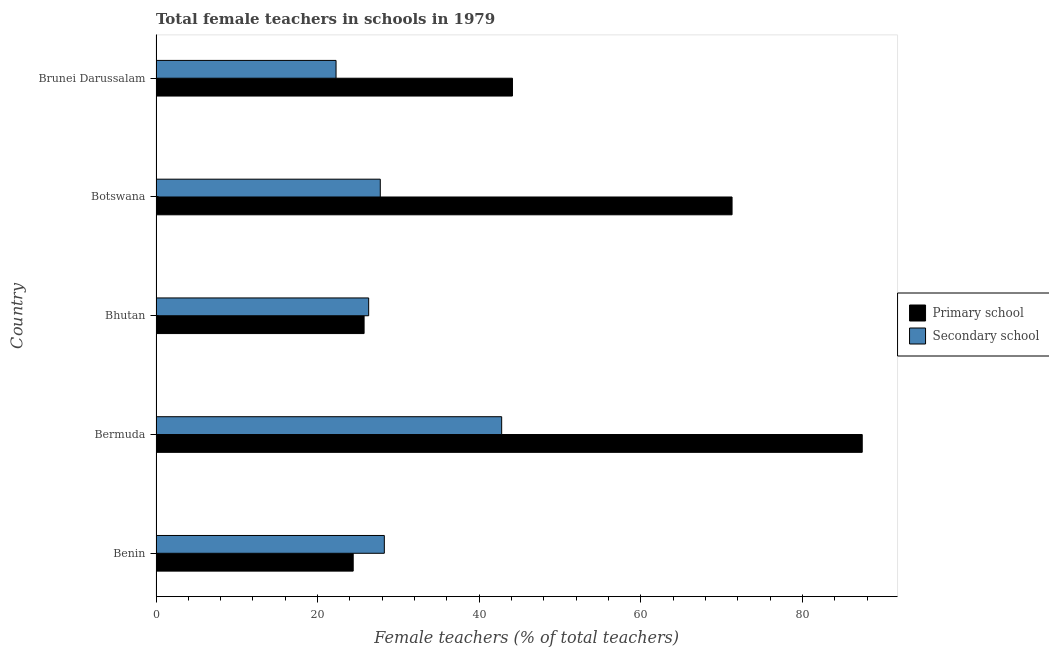How many different coloured bars are there?
Your response must be concise. 2. How many groups of bars are there?
Ensure brevity in your answer.  5. Are the number of bars per tick equal to the number of legend labels?
Your answer should be compact. Yes. Are the number of bars on each tick of the Y-axis equal?
Give a very brief answer. Yes. How many bars are there on the 2nd tick from the top?
Make the answer very short. 2. What is the label of the 1st group of bars from the top?
Provide a succinct answer. Brunei Darussalam. What is the percentage of female teachers in secondary schools in Brunei Darussalam?
Provide a short and direct response. 22.28. Across all countries, what is the maximum percentage of female teachers in primary schools?
Provide a short and direct response. 87.4. Across all countries, what is the minimum percentage of female teachers in primary schools?
Keep it short and to the point. 24.4. In which country was the percentage of female teachers in secondary schools maximum?
Your answer should be very brief. Bermuda. In which country was the percentage of female teachers in secondary schools minimum?
Make the answer very short. Brunei Darussalam. What is the total percentage of female teachers in primary schools in the graph?
Give a very brief answer. 252.97. What is the difference between the percentage of female teachers in primary schools in Benin and that in Botswana?
Make the answer very short. -46.89. What is the difference between the percentage of female teachers in secondary schools in Bermuda and the percentage of female teachers in primary schools in Brunei Darussalam?
Ensure brevity in your answer.  -1.34. What is the average percentage of female teachers in primary schools per country?
Keep it short and to the point. 50.59. What is the difference between the percentage of female teachers in primary schools and percentage of female teachers in secondary schools in Bermuda?
Your response must be concise. 44.62. In how many countries, is the percentage of female teachers in secondary schools greater than 16 %?
Your response must be concise. 5. What is the ratio of the percentage of female teachers in primary schools in Bhutan to that in Botswana?
Your response must be concise. 0.36. Is the difference between the percentage of female teachers in primary schools in Botswana and Brunei Darussalam greater than the difference between the percentage of female teachers in secondary schools in Botswana and Brunei Darussalam?
Offer a terse response. Yes. What is the difference between the highest and the second highest percentage of female teachers in primary schools?
Your response must be concise. 16.11. In how many countries, is the percentage of female teachers in primary schools greater than the average percentage of female teachers in primary schools taken over all countries?
Your response must be concise. 2. What does the 2nd bar from the top in Brunei Darussalam represents?
Your answer should be compact. Primary school. What does the 2nd bar from the bottom in Benin represents?
Keep it short and to the point. Secondary school. How many bars are there?
Offer a very short reply. 10. How many countries are there in the graph?
Provide a short and direct response. 5. What is the difference between two consecutive major ticks on the X-axis?
Keep it short and to the point. 20. Are the values on the major ticks of X-axis written in scientific E-notation?
Provide a succinct answer. No. Does the graph contain any zero values?
Make the answer very short. No. Does the graph contain grids?
Make the answer very short. No. Where does the legend appear in the graph?
Make the answer very short. Center right. How are the legend labels stacked?
Your answer should be very brief. Vertical. What is the title of the graph?
Your answer should be very brief. Total female teachers in schools in 1979. What is the label or title of the X-axis?
Provide a succinct answer. Female teachers (% of total teachers). What is the label or title of the Y-axis?
Provide a succinct answer. Country. What is the Female teachers (% of total teachers) in Primary school in Benin?
Your response must be concise. 24.4. What is the Female teachers (% of total teachers) in Secondary school in Benin?
Your answer should be very brief. 28.26. What is the Female teachers (% of total teachers) of Primary school in Bermuda?
Provide a short and direct response. 87.4. What is the Female teachers (% of total teachers) in Secondary school in Bermuda?
Offer a terse response. 42.78. What is the Female teachers (% of total teachers) in Primary school in Bhutan?
Your answer should be very brief. 25.75. What is the Female teachers (% of total teachers) of Secondary school in Bhutan?
Your answer should be compact. 26.32. What is the Female teachers (% of total teachers) in Primary school in Botswana?
Offer a terse response. 71.29. What is the Female teachers (% of total teachers) of Secondary school in Botswana?
Ensure brevity in your answer.  27.76. What is the Female teachers (% of total teachers) in Primary school in Brunei Darussalam?
Provide a short and direct response. 44.12. What is the Female teachers (% of total teachers) of Secondary school in Brunei Darussalam?
Ensure brevity in your answer.  22.28. Across all countries, what is the maximum Female teachers (% of total teachers) of Primary school?
Make the answer very short. 87.4. Across all countries, what is the maximum Female teachers (% of total teachers) in Secondary school?
Offer a very short reply. 42.78. Across all countries, what is the minimum Female teachers (% of total teachers) in Primary school?
Ensure brevity in your answer.  24.4. Across all countries, what is the minimum Female teachers (% of total teachers) in Secondary school?
Your answer should be compact. 22.28. What is the total Female teachers (% of total teachers) in Primary school in the graph?
Provide a short and direct response. 252.97. What is the total Female teachers (% of total teachers) in Secondary school in the graph?
Your response must be concise. 147.39. What is the difference between the Female teachers (% of total teachers) of Primary school in Benin and that in Bermuda?
Make the answer very short. -63. What is the difference between the Female teachers (% of total teachers) in Secondary school in Benin and that in Bermuda?
Offer a very short reply. -14.52. What is the difference between the Female teachers (% of total teachers) of Primary school in Benin and that in Bhutan?
Ensure brevity in your answer.  -1.35. What is the difference between the Female teachers (% of total teachers) in Secondary school in Benin and that in Bhutan?
Ensure brevity in your answer.  1.94. What is the difference between the Female teachers (% of total teachers) of Primary school in Benin and that in Botswana?
Make the answer very short. -46.89. What is the difference between the Female teachers (% of total teachers) of Secondary school in Benin and that in Botswana?
Your response must be concise. 0.5. What is the difference between the Female teachers (% of total teachers) of Primary school in Benin and that in Brunei Darussalam?
Offer a terse response. -19.71. What is the difference between the Female teachers (% of total teachers) of Secondary school in Benin and that in Brunei Darussalam?
Keep it short and to the point. 5.98. What is the difference between the Female teachers (% of total teachers) in Primary school in Bermuda and that in Bhutan?
Offer a terse response. 61.65. What is the difference between the Female teachers (% of total teachers) in Secondary school in Bermuda and that in Bhutan?
Give a very brief answer. 16.46. What is the difference between the Female teachers (% of total teachers) in Primary school in Bermuda and that in Botswana?
Ensure brevity in your answer.  16.11. What is the difference between the Female teachers (% of total teachers) of Secondary school in Bermuda and that in Botswana?
Offer a terse response. 15.02. What is the difference between the Female teachers (% of total teachers) of Primary school in Bermuda and that in Brunei Darussalam?
Offer a terse response. 43.29. What is the difference between the Female teachers (% of total teachers) of Secondary school in Bermuda and that in Brunei Darussalam?
Make the answer very short. 20.5. What is the difference between the Female teachers (% of total teachers) of Primary school in Bhutan and that in Botswana?
Offer a terse response. -45.54. What is the difference between the Female teachers (% of total teachers) in Secondary school in Bhutan and that in Botswana?
Provide a succinct answer. -1.44. What is the difference between the Female teachers (% of total teachers) in Primary school in Bhutan and that in Brunei Darussalam?
Ensure brevity in your answer.  -18.36. What is the difference between the Female teachers (% of total teachers) in Secondary school in Bhutan and that in Brunei Darussalam?
Provide a succinct answer. 4.04. What is the difference between the Female teachers (% of total teachers) of Primary school in Botswana and that in Brunei Darussalam?
Provide a short and direct response. 27.18. What is the difference between the Female teachers (% of total teachers) in Secondary school in Botswana and that in Brunei Darussalam?
Offer a very short reply. 5.47. What is the difference between the Female teachers (% of total teachers) of Primary school in Benin and the Female teachers (% of total teachers) of Secondary school in Bermuda?
Your response must be concise. -18.37. What is the difference between the Female teachers (% of total teachers) of Primary school in Benin and the Female teachers (% of total teachers) of Secondary school in Bhutan?
Your response must be concise. -1.91. What is the difference between the Female teachers (% of total teachers) in Primary school in Benin and the Female teachers (% of total teachers) in Secondary school in Botswana?
Ensure brevity in your answer.  -3.35. What is the difference between the Female teachers (% of total teachers) of Primary school in Benin and the Female teachers (% of total teachers) of Secondary school in Brunei Darussalam?
Provide a succinct answer. 2.12. What is the difference between the Female teachers (% of total teachers) in Primary school in Bermuda and the Female teachers (% of total teachers) in Secondary school in Bhutan?
Keep it short and to the point. 61.09. What is the difference between the Female teachers (% of total teachers) in Primary school in Bermuda and the Female teachers (% of total teachers) in Secondary school in Botswana?
Offer a terse response. 59.65. What is the difference between the Female teachers (% of total teachers) of Primary school in Bermuda and the Female teachers (% of total teachers) of Secondary school in Brunei Darussalam?
Your answer should be very brief. 65.12. What is the difference between the Female teachers (% of total teachers) of Primary school in Bhutan and the Female teachers (% of total teachers) of Secondary school in Botswana?
Your answer should be very brief. -2. What is the difference between the Female teachers (% of total teachers) in Primary school in Bhutan and the Female teachers (% of total teachers) in Secondary school in Brunei Darussalam?
Make the answer very short. 3.47. What is the difference between the Female teachers (% of total teachers) of Primary school in Botswana and the Female teachers (% of total teachers) of Secondary school in Brunei Darussalam?
Give a very brief answer. 49.01. What is the average Female teachers (% of total teachers) of Primary school per country?
Keep it short and to the point. 50.59. What is the average Female teachers (% of total teachers) of Secondary school per country?
Offer a very short reply. 29.48. What is the difference between the Female teachers (% of total teachers) in Primary school and Female teachers (% of total teachers) in Secondary school in Benin?
Make the answer very short. -3.85. What is the difference between the Female teachers (% of total teachers) of Primary school and Female teachers (% of total teachers) of Secondary school in Bermuda?
Ensure brevity in your answer.  44.63. What is the difference between the Female teachers (% of total teachers) in Primary school and Female teachers (% of total teachers) in Secondary school in Bhutan?
Give a very brief answer. -0.57. What is the difference between the Female teachers (% of total teachers) in Primary school and Female teachers (% of total teachers) in Secondary school in Botswana?
Keep it short and to the point. 43.54. What is the difference between the Female teachers (% of total teachers) in Primary school and Female teachers (% of total teachers) in Secondary school in Brunei Darussalam?
Offer a very short reply. 21.84. What is the ratio of the Female teachers (% of total teachers) of Primary school in Benin to that in Bermuda?
Keep it short and to the point. 0.28. What is the ratio of the Female teachers (% of total teachers) of Secondary school in Benin to that in Bermuda?
Ensure brevity in your answer.  0.66. What is the ratio of the Female teachers (% of total teachers) of Primary school in Benin to that in Bhutan?
Provide a succinct answer. 0.95. What is the ratio of the Female teachers (% of total teachers) of Secondary school in Benin to that in Bhutan?
Your response must be concise. 1.07. What is the ratio of the Female teachers (% of total teachers) of Primary school in Benin to that in Botswana?
Provide a short and direct response. 0.34. What is the ratio of the Female teachers (% of total teachers) in Secondary school in Benin to that in Botswana?
Give a very brief answer. 1.02. What is the ratio of the Female teachers (% of total teachers) in Primary school in Benin to that in Brunei Darussalam?
Ensure brevity in your answer.  0.55. What is the ratio of the Female teachers (% of total teachers) of Secondary school in Benin to that in Brunei Darussalam?
Your answer should be very brief. 1.27. What is the ratio of the Female teachers (% of total teachers) of Primary school in Bermuda to that in Bhutan?
Ensure brevity in your answer.  3.39. What is the ratio of the Female teachers (% of total teachers) in Secondary school in Bermuda to that in Bhutan?
Ensure brevity in your answer.  1.63. What is the ratio of the Female teachers (% of total teachers) in Primary school in Bermuda to that in Botswana?
Your answer should be very brief. 1.23. What is the ratio of the Female teachers (% of total teachers) in Secondary school in Bermuda to that in Botswana?
Keep it short and to the point. 1.54. What is the ratio of the Female teachers (% of total teachers) of Primary school in Bermuda to that in Brunei Darussalam?
Ensure brevity in your answer.  1.98. What is the ratio of the Female teachers (% of total teachers) of Secondary school in Bermuda to that in Brunei Darussalam?
Offer a very short reply. 1.92. What is the ratio of the Female teachers (% of total teachers) of Primary school in Bhutan to that in Botswana?
Give a very brief answer. 0.36. What is the ratio of the Female teachers (% of total teachers) in Secondary school in Bhutan to that in Botswana?
Offer a terse response. 0.95. What is the ratio of the Female teachers (% of total teachers) in Primary school in Bhutan to that in Brunei Darussalam?
Your response must be concise. 0.58. What is the ratio of the Female teachers (% of total teachers) in Secondary school in Bhutan to that in Brunei Darussalam?
Give a very brief answer. 1.18. What is the ratio of the Female teachers (% of total teachers) of Primary school in Botswana to that in Brunei Darussalam?
Keep it short and to the point. 1.62. What is the ratio of the Female teachers (% of total teachers) of Secondary school in Botswana to that in Brunei Darussalam?
Your response must be concise. 1.25. What is the difference between the highest and the second highest Female teachers (% of total teachers) of Primary school?
Offer a terse response. 16.11. What is the difference between the highest and the second highest Female teachers (% of total teachers) in Secondary school?
Make the answer very short. 14.52. What is the difference between the highest and the lowest Female teachers (% of total teachers) of Primary school?
Offer a very short reply. 63. What is the difference between the highest and the lowest Female teachers (% of total teachers) of Secondary school?
Offer a very short reply. 20.5. 